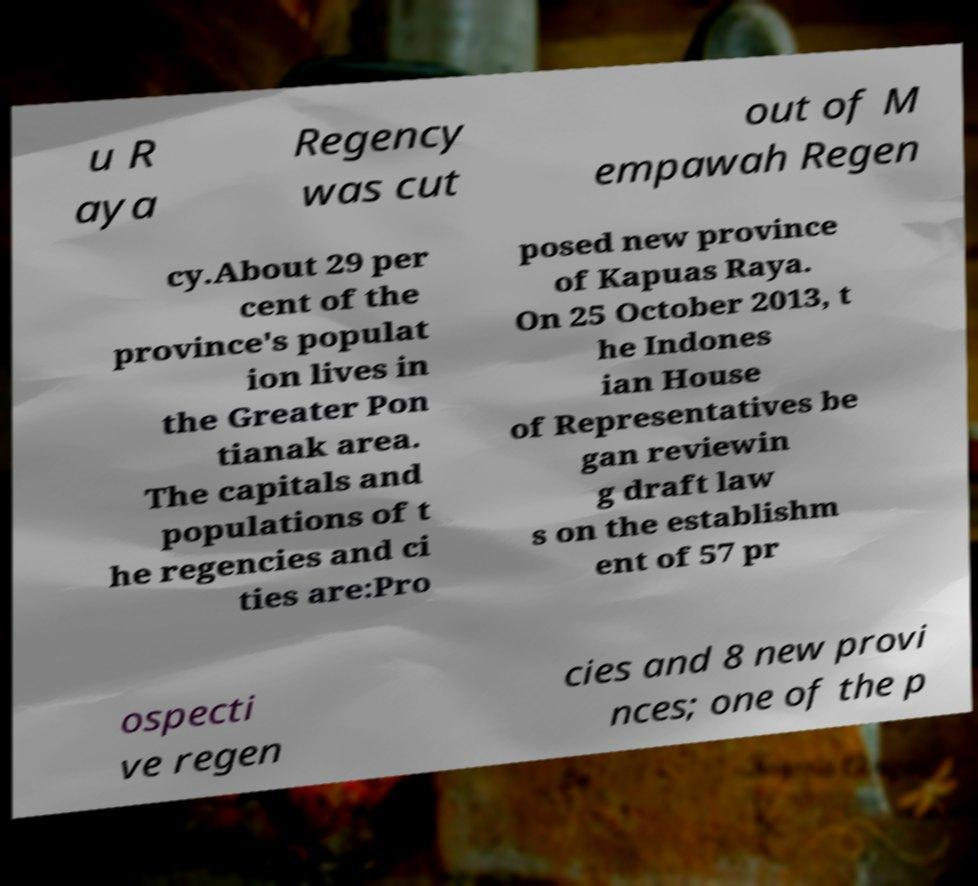There's text embedded in this image that I need extracted. Can you transcribe it verbatim? u R aya Regency was cut out of M empawah Regen cy.About 29 per cent of the province's populat ion lives in the Greater Pon tianak area. The capitals and populations of t he regencies and ci ties are:Pro posed new province of Kapuas Raya. On 25 October 2013, t he Indones ian House of Representatives be gan reviewin g draft law s on the establishm ent of 57 pr ospecti ve regen cies and 8 new provi nces; one of the p 